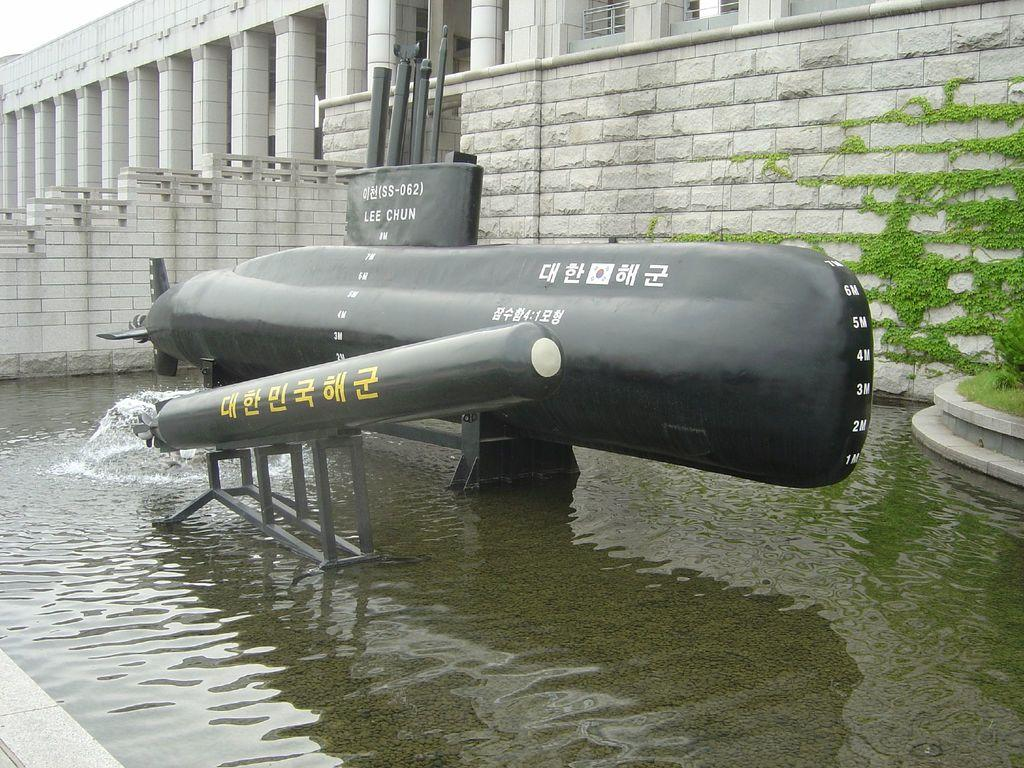What is the main subject in the center of the image? There is a pipeline in the center of the image. What can be seen at the bottom of the image? There is water at the bottom of the image. What is visible in the background of the image? There is a building in the background of the image. What type of vegetation is on the right side of the image? There is a plant on the right side of the image. What type of cushion is being used to support the pipeline in the image? There is no cushion present in the image; the pipeline is not supported by any cushion. 